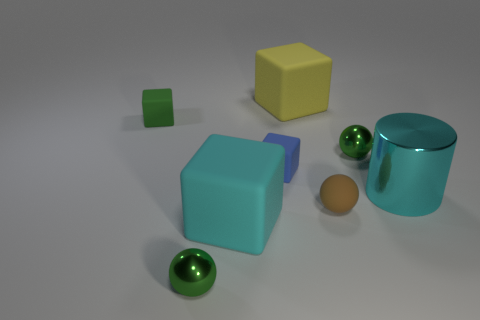Subtract all red cubes. Subtract all yellow balls. How many cubes are left? 4 Add 2 tiny brown things. How many objects exist? 10 Subtract all cylinders. How many objects are left? 7 Add 1 large gray rubber blocks. How many large gray rubber blocks exist? 1 Subtract 0 gray blocks. How many objects are left? 8 Subtract all tiny blue matte blocks. Subtract all cyan metal objects. How many objects are left? 6 Add 4 big metal objects. How many big metal objects are left? 5 